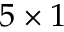Convert formula to latex. <formula><loc_0><loc_0><loc_500><loc_500>5 \times 1</formula> 